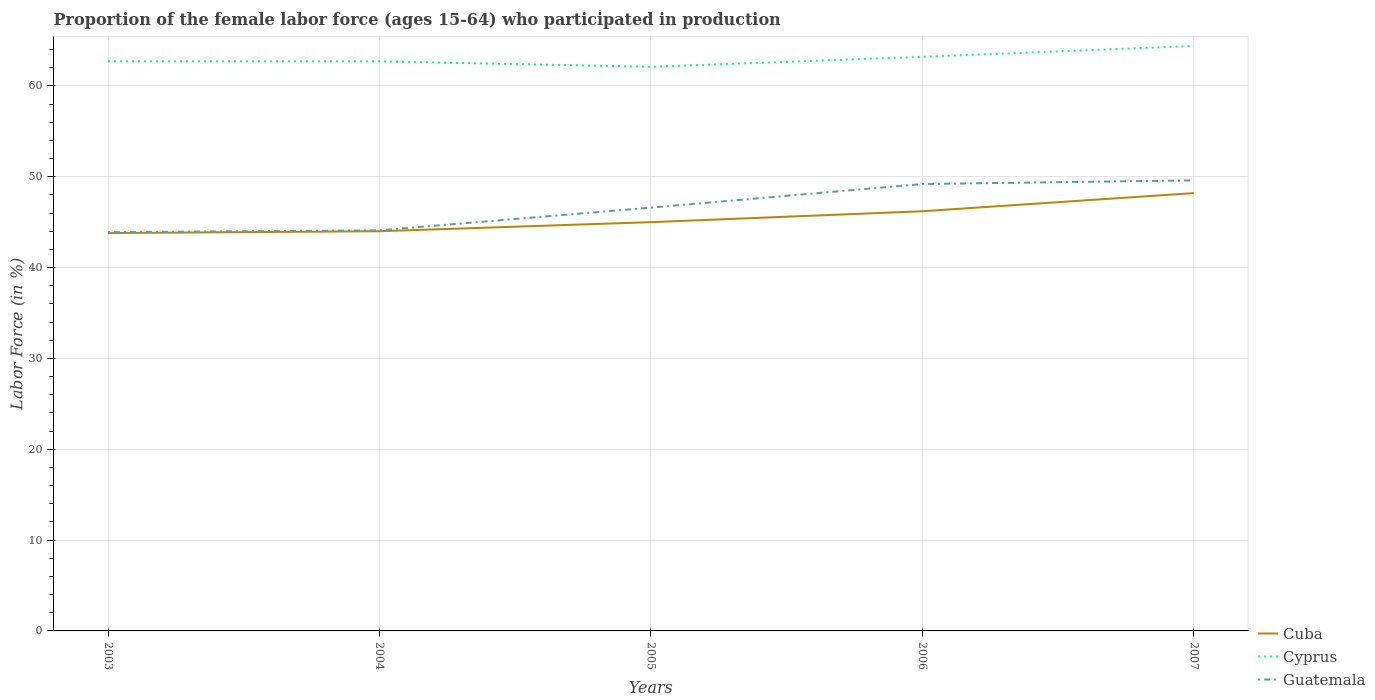How many different coloured lines are there?
Provide a succinct answer. 3. Across all years, what is the maximum proportion of the female labor force who participated in production in Guatemala?
Your response must be concise. 43.9. In which year was the proportion of the female labor force who participated in production in Guatemala maximum?
Provide a succinct answer. 2003. What is the total proportion of the female labor force who participated in production in Guatemala in the graph?
Provide a short and direct response. -0.4. What is the difference between the highest and the second highest proportion of the female labor force who participated in production in Guatemala?
Provide a short and direct response. 5.7. How many lines are there?
Provide a short and direct response. 3. Where does the legend appear in the graph?
Your answer should be very brief. Bottom right. What is the title of the graph?
Your answer should be very brief. Proportion of the female labor force (ages 15-64) who participated in production. Does "West Bank and Gaza" appear as one of the legend labels in the graph?
Make the answer very short. No. What is the label or title of the X-axis?
Offer a terse response. Years. What is the label or title of the Y-axis?
Give a very brief answer. Labor Force (in %). What is the Labor Force (in %) of Cuba in 2003?
Make the answer very short. 43.8. What is the Labor Force (in %) in Cyprus in 2003?
Provide a succinct answer. 62.7. What is the Labor Force (in %) of Guatemala in 2003?
Provide a short and direct response. 43.9. What is the Labor Force (in %) of Cyprus in 2004?
Your answer should be very brief. 62.7. What is the Labor Force (in %) of Guatemala in 2004?
Provide a succinct answer. 44.1. What is the Labor Force (in %) in Cyprus in 2005?
Provide a succinct answer. 62.1. What is the Labor Force (in %) of Guatemala in 2005?
Keep it short and to the point. 46.6. What is the Labor Force (in %) in Cuba in 2006?
Keep it short and to the point. 46.2. What is the Labor Force (in %) of Cyprus in 2006?
Make the answer very short. 63.2. What is the Labor Force (in %) of Guatemala in 2006?
Your answer should be very brief. 49.2. What is the Labor Force (in %) of Cuba in 2007?
Ensure brevity in your answer.  48.2. What is the Labor Force (in %) in Cyprus in 2007?
Provide a short and direct response. 64.4. What is the Labor Force (in %) in Guatemala in 2007?
Make the answer very short. 49.6. Across all years, what is the maximum Labor Force (in %) in Cuba?
Your answer should be very brief. 48.2. Across all years, what is the maximum Labor Force (in %) in Cyprus?
Provide a succinct answer. 64.4. Across all years, what is the maximum Labor Force (in %) of Guatemala?
Offer a terse response. 49.6. Across all years, what is the minimum Labor Force (in %) of Cuba?
Provide a succinct answer. 43.8. Across all years, what is the minimum Labor Force (in %) in Cyprus?
Provide a short and direct response. 62.1. Across all years, what is the minimum Labor Force (in %) of Guatemala?
Make the answer very short. 43.9. What is the total Labor Force (in %) in Cuba in the graph?
Make the answer very short. 227.2. What is the total Labor Force (in %) of Cyprus in the graph?
Your answer should be compact. 315.1. What is the total Labor Force (in %) of Guatemala in the graph?
Your response must be concise. 233.4. What is the difference between the Labor Force (in %) of Cuba in 2003 and that in 2004?
Give a very brief answer. -0.2. What is the difference between the Labor Force (in %) of Guatemala in 2003 and that in 2004?
Give a very brief answer. -0.2. What is the difference between the Labor Force (in %) of Guatemala in 2003 and that in 2005?
Your response must be concise. -2.7. What is the difference between the Labor Force (in %) of Cuba in 2003 and that in 2006?
Provide a succinct answer. -2.4. What is the difference between the Labor Force (in %) of Cyprus in 2004 and that in 2006?
Offer a very short reply. -0.5. What is the difference between the Labor Force (in %) in Guatemala in 2004 and that in 2006?
Keep it short and to the point. -5.1. What is the difference between the Labor Force (in %) in Cuba in 2004 and that in 2007?
Offer a very short reply. -4.2. What is the difference between the Labor Force (in %) in Cyprus in 2004 and that in 2007?
Your response must be concise. -1.7. What is the difference between the Labor Force (in %) in Guatemala in 2004 and that in 2007?
Offer a very short reply. -5.5. What is the difference between the Labor Force (in %) in Cuba in 2005 and that in 2006?
Make the answer very short. -1.2. What is the difference between the Labor Force (in %) in Guatemala in 2005 and that in 2006?
Keep it short and to the point. -2.6. What is the difference between the Labor Force (in %) of Cuba in 2005 and that in 2007?
Provide a succinct answer. -3.2. What is the difference between the Labor Force (in %) in Cyprus in 2005 and that in 2007?
Offer a terse response. -2.3. What is the difference between the Labor Force (in %) in Guatemala in 2005 and that in 2007?
Ensure brevity in your answer.  -3. What is the difference between the Labor Force (in %) in Cuba in 2006 and that in 2007?
Make the answer very short. -2. What is the difference between the Labor Force (in %) of Cuba in 2003 and the Labor Force (in %) of Cyprus in 2004?
Offer a very short reply. -18.9. What is the difference between the Labor Force (in %) of Cuba in 2003 and the Labor Force (in %) of Guatemala in 2004?
Provide a short and direct response. -0.3. What is the difference between the Labor Force (in %) in Cuba in 2003 and the Labor Force (in %) in Cyprus in 2005?
Keep it short and to the point. -18.3. What is the difference between the Labor Force (in %) of Cuba in 2003 and the Labor Force (in %) of Cyprus in 2006?
Provide a succinct answer. -19.4. What is the difference between the Labor Force (in %) in Cuba in 2003 and the Labor Force (in %) in Cyprus in 2007?
Your answer should be very brief. -20.6. What is the difference between the Labor Force (in %) in Cuba in 2003 and the Labor Force (in %) in Guatemala in 2007?
Give a very brief answer. -5.8. What is the difference between the Labor Force (in %) in Cyprus in 2003 and the Labor Force (in %) in Guatemala in 2007?
Your answer should be very brief. 13.1. What is the difference between the Labor Force (in %) in Cuba in 2004 and the Labor Force (in %) in Cyprus in 2005?
Ensure brevity in your answer.  -18.1. What is the difference between the Labor Force (in %) in Cuba in 2004 and the Labor Force (in %) in Guatemala in 2005?
Offer a terse response. -2.6. What is the difference between the Labor Force (in %) of Cuba in 2004 and the Labor Force (in %) of Cyprus in 2006?
Your answer should be very brief. -19.2. What is the difference between the Labor Force (in %) in Cuba in 2004 and the Labor Force (in %) in Guatemala in 2006?
Ensure brevity in your answer.  -5.2. What is the difference between the Labor Force (in %) in Cyprus in 2004 and the Labor Force (in %) in Guatemala in 2006?
Provide a short and direct response. 13.5. What is the difference between the Labor Force (in %) of Cuba in 2004 and the Labor Force (in %) of Cyprus in 2007?
Offer a very short reply. -20.4. What is the difference between the Labor Force (in %) in Cuba in 2004 and the Labor Force (in %) in Guatemala in 2007?
Your answer should be very brief. -5.6. What is the difference between the Labor Force (in %) of Cyprus in 2004 and the Labor Force (in %) of Guatemala in 2007?
Offer a terse response. 13.1. What is the difference between the Labor Force (in %) of Cuba in 2005 and the Labor Force (in %) of Cyprus in 2006?
Give a very brief answer. -18.2. What is the difference between the Labor Force (in %) in Cuba in 2005 and the Labor Force (in %) in Cyprus in 2007?
Make the answer very short. -19.4. What is the difference between the Labor Force (in %) in Cuba in 2005 and the Labor Force (in %) in Guatemala in 2007?
Keep it short and to the point. -4.6. What is the difference between the Labor Force (in %) of Cuba in 2006 and the Labor Force (in %) of Cyprus in 2007?
Offer a very short reply. -18.2. What is the difference between the Labor Force (in %) of Cuba in 2006 and the Labor Force (in %) of Guatemala in 2007?
Your response must be concise. -3.4. What is the average Labor Force (in %) in Cuba per year?
Offer a very short reply. 45.44. What is the average Labor Force (in %) in Cyprus per year?
Your answer should be compact. 63.02. What is the average Labor Force (in %) of Guatemala per year?
Provide a short and direct response. 46.68. In the year 2003, what is the difference between the Labor Force (in %) of Cuba and Labor Force (in %) of Cyprus?
Offer a terse response. -18.9. In the year 2003, what is the difference between the Labor Force (in %) in Cuba and Labor Force (in %) in Guatemala?
Your answer should be very brief. -0.1. In the year 2004, what is the difference between the Labor Force (in %) of Cuba and Labor Force (in %) of Cyprus?
Give a very brief answer. -18.7. In the year 2004, what is the difference between the Labor Force (in %) of Cuba and Labor Force (in %) of Guatemala?
Make the answer very short. -0.1. In the year 2005, what is the difference between the Labor Force (in %) in Cuba and Labor Force (in %) in Cyprus?
Provide a succinct answer. -17.1. In the year 2005, what is the difference between the Labor Force (in %) of Cuba and Labor Force (in %) of Guatemala?
Offer a terse response. -1.6. In the year 2005, what is the difference between the Labor Force (in %) of Cyprus and Labor Force (in %) of Guatemala?
Your response must be concise. 15.5. In the year 2006, what is the difference between the Labor Force (in %) in Cuba and Labor Force (in %) in Cyprus?
Keep it short and to the point. -17. In the year 2006, what is the difference between the Labor Force (in %) in Cyprus and Labor Force (in %) in Guatemala?
Keep it short and to the point. 14. In the year 2007, what is the difference between the Labor Force (in %) in Cuba and Labor Force (in %) in Cyprus?
Keep it short and to the point. -16.2. In the year 2007, what is the difference between the Labor Force (in %) of Cyprus and Labor Force (in %) of Guatemala?
Ensure brevity in your answer.  14.8. What is the ratio of the Labor Force (in %) of Cuba in 2003 to that in 2004?
Offer a terse response. 1. What is the ratio of the Labor Force (in %) of Guatemala in 2003 to that in 2004?
Provide a succinct answer. 1. What is the ratio of the Labor Force (in %) in Cuba in 2003 to that in 2005?
Give a very brief answer. 0.97. What is the ratio of the Labor Force (in %) in Cyprus in 2003 to that in 2005?
Provide a short and direct response. 1.01. What is the ratio of the Labor Force (in %) of Guatemala in 2003 to that in 2005?
Provide a succinct answer. 0.94. What is the ratio of the Labor Force (in %) of Cuba in 2003 to that in 2006?
Give a very brief answer. 0.95. What is the ratio of the Labor Force (in %) of Guatemala in 2003 to that in 2006?
Give a very brief answer. 0.89. What is the ratio of the Labor Force (in %) in Cuba in 2003 to that in 2007?
Provide a succinct answer. 0.91. What is the ratio of the Labor Force (in %) of Cyprus in 2003 to that in 2007?
Offer a very short reply. 0.97. What is the ratio of the Labor Force (in %) in Guatemala in 2003 to that in 2007?
Give a very brief answer. 0.89. What is the ratio of the Labor Force (in %) in Cuba in 2004 to that in 2005?
Give a very brief answer. 0.98. What is the ratio of the Labor Force (in %) in Cyprus in 2004 to that in 2005?
Give a very brief answer. 1.01. What is the ratio of the Labor Force (in %) of Guatemala in 2004 to that in 2005?
Provide a succinct answer. 0.95. What is the ratio of the Labor Force (in %) in Cuba in 2004 to that in 2006?
Provide a succinct answer. 0.95. What is the ratio of the Labor Force (in %) of Guatemala in 2004 to that in 2006?
Provide a succinct answer. 0.9. What is the ratio of the Labor Force (in %) in Cuba in 2004 to that in 2007?
Your response must be concise. 0.91. What is the ratio of the Labor Force (in %) in Cyprus in 2004 to that in 2007?
Your answer should be very brief. 0.97. What is the ratio of the Labor Force (in %) in Guatemala in 2004 to that in 2007?
Offer a very short reply. 0.89. What is the ratio of the Labor Force (in %) in Cuba in 2005 to that in 2006?
Give a very brief answer. 0.97. What is the ratio of the Labor Force (in %) of Cyprus in 2005 to that in 2006?
Offer a terse response. 0.98. What is the ratio of the Labor Force (in %) in Guatemala in 2005 to that in 2006?
Keep it short and to the point. 0.95. What is the ratio of the Labor Force (in %) in Cuba in 2005 to that in 2007?
Your response must be concise. 0.93. What is the ratio of the Labor Force (in %) in Guatemala in 2005 to that in 2007?
Keep it short and to the point. 0.94. What is the ratio of the Labor Force (in %) of Cuba in 2006 to that in 2007?
Ensure brevity in your answer.  0.96. What is the ratio of the Labor Force (in %) in Cyprus in 2006 to that in 2007?
Provide a short and direct response. 0.98. What is the difference between the highest and the second highest Labor Force (in %) of Cuba?
Provide a succinct answer. 2. What is the difference between the highest and the second highest Labor Force (in %) in Cyprus?
Your answer should be compact. 1.2. What is the difference between the highest and the lowest Labor Force (in %) of Cyprus?
Keep it short and to the point. 2.3. 